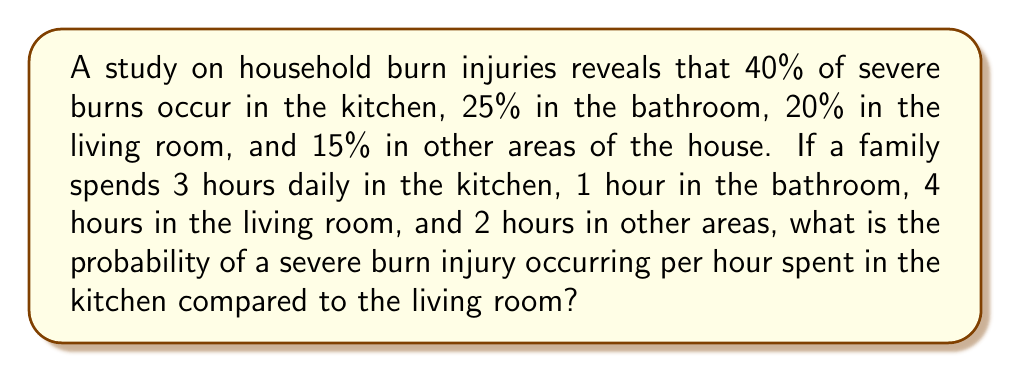Provide a solution to this math problem. To solve this problem, we need to calculate the probability of a severe burn injury per hour for both the kitchen and the living room, then compare them.

Step 1: Calculate the total time spent in the house.
Total time = 3 + 1 + 4 + 2 = 10 hours

Step 2: Calculate the probability of a severe burn injury per hour in the kitchen.
Kitchen probability per hour = $\frac{\text{Probability of burn in kitchen}}{\text{Time spent in kitchen}}$ = $\frac{0.40}{3}$ = $\frac{4}{30}$ = $0.1333$

Step 3: Calculate the probability of a severe burn injury per hour in the living room.
Living room probability per hour = $\frac{\text{Probability of burn in living room}}{\text{Time spent in living room}}$ = $\frac{0.20}{4}$ = $\frac{1}{20}$ = $0.05$

Step 4: Calculate the ratio of kitchen probability to living room probability.
Ratio = $\frac{\text{Kitchen probability per hour}}{\text{Living room probability per hour}}$ = $\frac{0.1333}{0.05}$ = $\frac{4/30}{1/20}$ = $\frac{4 \times 20}{30 \times 1}$ = $\frac{80}{30}$ = $\frac{8}{3}$ ≈ 2.67

Therefore, the probability of a severe burn injury occurring per hour spent in the kitchen is about 2.67 times higher than in the living room.
Answer: $\frac{8}{3}$ or approximately 2.67 times higher 